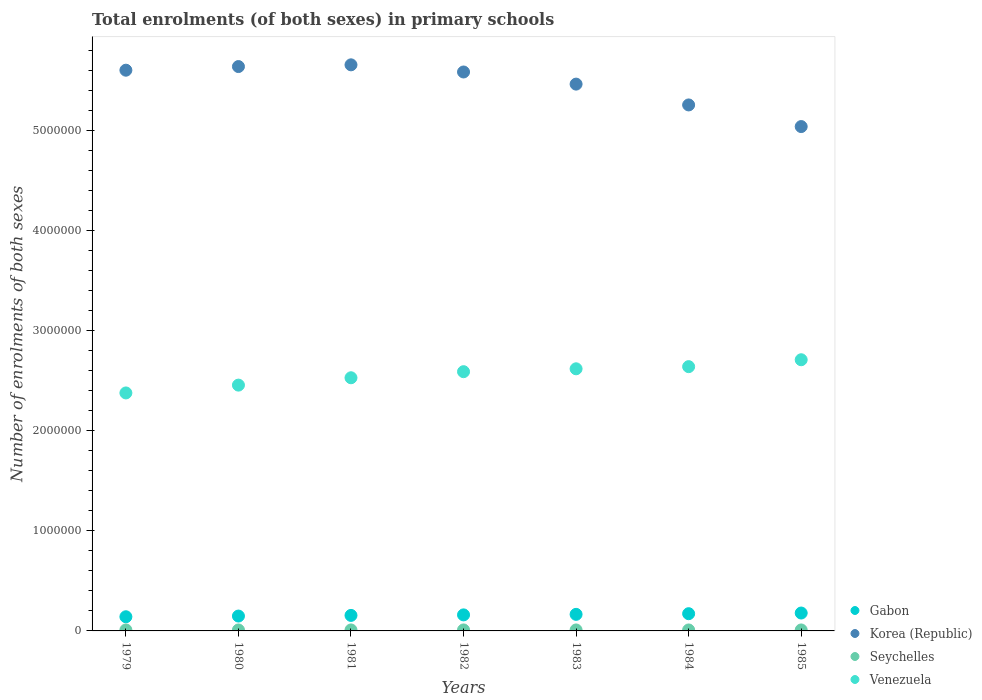What is the number of enrolments in primary schools in Korea (Republic) in 1980?
Provide a succinct answer. 5.64e+06. Across all years, what is the maximum number of enrolments in primary schools in Gabon?
Provide a succinct answer. 1.79e+05. Across all years, what is the minimum number of enrolments in primary schools in Venezuela?
Provide a short and direct response. 2.38e+06. In which year was the number of enrolments in primary schools in Seychelles maximum?
Your answer should be compact. 1979. In which year was the number of enrolments in primary schools in Venezuela minimum?
Give a very brief answer. 1979. What is the total number of enrolments in primary schools in Gabon in the graph?
Make the answer very short. 1.12e+06. What is the difference between the number of enrolments in primary schools in Seychelles in 1979 and that in 1980?
Ensure brevity in your answer.  349. What is the difference between the number of enrolments in primary schools in Seychelles in 1983 and the number of enrolments in primary schools in Gabon in 1981?
Offer a very short reply. -1.45e+05. What is the average number of enrolments in primary schools in Gabon per year?
Provide a short and direct response. 1.60e+05. In the year 1980, what is the difference between the number of enrolments in primary schools in Seychelles and number of enrolments in primary schools in Korea (Republic)?
Your answer should be very brief. -5.63e+06. In how many years, is the number of enrolments in primary schools in Gabon greater than 800000?
Provide a short and direct response. 0. What is the ratio of the number of enrolments in primary schools in Seychelles in 1983 to that in 1985?
Provide a succinct answer. 1.01. Is the number of enrolments in primary schools in Gabon in 1982 less than that in 1984?
Give a very brief answer. Yes. What is the difference between the highest and the second highest number of enrolments in primary schools in Gabon?
Offer a very short reply. 6612. What is the difference between the highest and the lowest number of enrolments in primary schools in Seychelles?
Provide a short and direct response. 371. In how many years, is the number of enrolments in primary schools in Korea (Republic) greater than the average number of enrolments in primary schools in Korea (Republic) taken over all years?
Offer a very short reply. 5. Is it the case that in every year, the sum of the number of enrolments in primary schools in Gabon and number of enrolments in primary schools in Venezuela  is greater than the sum of number of enrolments in primary schools in Korea (Republic) and number of enrolments in primary schools in Seychelles?
Offer a very short reply. No. Does the number of enrolments in primary schools in Korea (Republic) monotonically increase over the years?
Provide a short and direct response. No. Is the number of enrolments in primary schools in Seychelles strictly less than the number of enrolments in primary schools in Venezuela over the years?
Ensure brevity in your answer.  Yes. How many dotlines are there?
Your answer should be very brief. 4. How many years are there in the graph?
Your answer should be very brief. 7. Does the graph contain any zero values?
Give a very brief answer. No. Does the graph contain grids?
Make the answer very short. No. Where does the legend appear in the graph?
Provide a succinct answer. Bottom right. How many legend labels are there?
Offer a very short reply. 4. What is the title of the graph?
Your answer should be very brief. Total enrolments (of both sexes) in primary schools. What is the label or title of the Y-axis?
Your response must be concise. Number of enrolments of both sexes. What is the Number of enrolments of both sexes of Gabon in 1979?
Your answer should be compact. 1.42e+05. What is the Number of enrolments of both sexes of Korea (Republic) in 1979?
Provide a short and direct response. 5.60e+06. What is the Number of enrolments of both sexes in Seychelles in 1979?
Provide a short and direct response. 9978. What is the Number of enrolments of both sexes of Venezuela in 1979?
Give a very brief answer. 2.38e+06. What is the Number of enrolments of both sexes in Gabon in 1980?
Offer a very short reply. 1.49e+05. What is the Number of enrolments of both sexes in Korea (Republic) in 1980?
Give a very brief answer. 5.64e+06. What is the Number of enrolments of both sexes of Seychelles in 1980?
Keep it short and to the point. 9629. What is the Number of enrolments of both sexes in Venezuela in 1980?
Make the answer very short. 2.46e+06. What is the Number of enrolments of both sexes of Gabon in 1981?
Give a very brief answer. 1.55e+05. What is the Number of enrolments of both sexes in Korea (Republic) in 1981?
Ensure brevity in your answer.  5.66e+06. What is the Number of enrolments of both sexes of Seychelles in 1981?
Your response must be concise. 9790. What is the Number of enrolments of both sexes of Venezuela in 1981?
Keep it short and to the point. 2.53e+06. What is the Number of enrolments of both sexes in Gabon in 1982?
Offer a terse response. 1.60e+05. What is the Number of enrolments of both sexes in Korea (Republic) in 1982?
Offer a very short reply. 5.59e+06. What is the Number of enrolments of both sexes in Seychelles in 1982?
Ensure brevity in your answer.  9897. What is the Number of enrolments of both sexes in Venezuela in 1982?
Offer a terse response. 2.59e+06. What is the Number of enrolments of both sexes in Gabon in 1983?
Provide a short and direct response. 1.66e+05. What is the Number of enrolments of both sexes in Korea (Republic) in 1983?
Your answer should be compact. 5.47e+06. What is the Number of enrolments of both sexes in Seychelles in 1983?
Offer a very short reply. 9820. What is the Number of enrolments of both sexes in Venezuela in 1983?
Your answer should be very brief. 2.62e+06. What is the Number of enrolments of both sexes in Gabon in 1984?
Offer a terse response. 1.72e+05. What is the Number of enrolments of both sexes in Korea (Republic) in 1984?
Keep it short and to the point. 5.26e+06. What is the Number of enrolments of both sexes in Seychelles in 1984?
Ensure brevity in your answer.  9607. What is the Number of enrolments of both sexes of Venezuela in 1984?
Provide a succinct answer. 2.64e+06. What is the Number of enrolments of both sexes in Gabon in 1985?
Ensure brevity in your answer.  1.79e+05. What is the Number of enrolments of both sexes of Korea (Republic) in 1985?
Your answer should be compact. 5.04e+06. What is the Number of enrolments of both sexes in Seychelles in 1985?
Make the answer very short. 9678. What is the Number of enrolments of both sexes of Venezuela in 1985?
Your answer should be very brief. 2.71e+06. Across all years, what is the maximum Number of enrolments of both sexes in Gabon?
Offer a terse response. 1.79e+05. Across all years, what is the maximum Number of enrolments of both sexes in Korea (Republic)?
Provide a succinct answer. 5.66e+06. Across all years, what is the maximum Number of enrolments of both sexes of Seychelles?
Provide a short and direct response. 9978. Across all years, what is the maximum Number of enrolments of both sexes in Venezuela?
Keep it short and to the point. 2.71e+06. Across all years, what is the minimum Number of enrolments of both sexes in Gabon?
Offer a very short reply. 1.42e+05. Across all years, what is the minimum Number of enrolments of both sexes of Korea (Republic)?
Make the answer very short. 5.04e+06. Across all years, what is the minimum Number of enrolments of both sexes in Seychelles?
Your response must be concise. 9607. Across all years, what is the minimum Number of enrolments of both sexes of Venezuela?
Your response must be concise. 2.38e+06. What is the total Number of enrolments of both sexes in Gabon in the graph?
Provide a succinct answer. 1.12e+06. What is the total Number of enrolments of both sexes of Korea (Republic) in the graph?
Provide a short and direct response. 3.83e+07. What is the total Number of enrolments of both sexes in Seychelles in the graph?
Offer a terse response. 6.84e+04. What is the total Number of enrolments of both sexes in Venezuela in the graph?
Your answer should be compact. 1.79e+07. What is the difference between the Number of enrolments of both sexes in Gabon in 1979 and that in 1980?
Offer a terse response. -6951. What is the difference between the Number of enrolments of both sexes of Korea (Republic) in 1979 and that in 1980?
Provide a succinct answer. -3.63e+04. What is the difference between the Number of enrolments of both sexes in Seychelles in 1979 and that in 1980?
Your response must be concise. 349. What is the difference between the Number of enrolments of both sexes of Venezuela in 1979 and that in 1980?
Offer a terse response. -7.82e+04. What is the difference between the Number of enrolments of both sexes in Gabon in 1979 and that in 1981?
Your answer should be compact. -1.35e+04. What is the difference between the Number of enrolments of both sexes in Korea (Republic) in 1979 and that in 1981?
Ensure brevity in your answer.  -5.36e+04. What is the difference between the Number of enrolments of both sexes in Seychelles in 1979 and that in 1981?
Provide a short and direct response. 188. What is the difference between the Number of enrolments of both sexes in Venezuela in 1979 and that in 1981?
Your answer should be compact. -1.52e+05. What is the difference between the Number of enrolments of both sexes in Gabon in 1979 and that in 1982?
Provide a succinct answer. -1.88e+04. What is the difference between the Number of enrolments of both sexes in Korea (Republic) in 1979 and that in 1982?
Provide a succinct answer. 1.79e+04. What is the difference between the Number of enrolments of both sexes of Seychelles in 1979 and that in 1982?
Give a very brief answer. 81. What is the difference between the Number of enrolments of both sexes in Venezuela in 1979 and that in 1982?
Your response must be concise. -2.12e+05. What is the difference between the Number of enrolments of both sexes in Gabon in 1979 and that in 1983?
Provide a succinct answer. -2.40e+04. What is the difference between the Number of enrolments of both sexes in Korea (Republic) in 1979 and that in 1983?
Your answer should be very brief. 1.39e+05. What is the difference between the Number of enrolments of both sexes of Seychelles in 1979 and that in 1983?
Provide a succinct answer. 158. What is the difference between the Number of enrolments of both sexes in Venezuela in 1979 and that in 1983?
Provide a succinct answer. -2.41e+05. What is the difference between the Number of enrolments of both sexes in Gabon in 1979 and that in 1984?
Give a very brief answer. -3.06e+04. What is the difference between the Number of enrolments of both sexes in Korea (Republic) in 1979 and that in 1984?
Offer a terse response. 3.47e+05. What is the difference between the Number of enrolments of both sexes of Seychelles in 1979 and that in 1984?
Give a very brief answer. 371. What is the difference between the Number of enrolments of both sexes of Venezuela in 1979 and that in 1984?
Offer a very short reply. -2.63e+05. What is the difference between the Number of enrolments of both sexes of Gabon in 1979 and that in 1985?
Keep it short and to the point. -3.72e+04. What is the difference between the Number of enrolments of both sexes in Korea (Republic) in 1979 and that in 1985?
Keep it short and to the point. 5.63e+05. What is the difference between the Number of enrolments of both sexes of Seychelles in 1979 and that in 1985?
Provide a short and direct response. 300. What is the difference between the Number of enrolments of both sexes of Venezuela in 1979 and that in 1985?
Give a very brief answer. -3.32e+05. What is the difference between the Number of enrolments of both sexes of Gabon in 1980 and that in 1981?
Keep it short and to the point. -6561. What is the difference between the Number of enrolments of both sexes in Korea (Republic) in 1980 and that in 1981?
Provide a short and direct response. -1.73e+04. What is the difference between the Number of enrolments of both sexes in Seychelles in 1980 and that in 1981?
Offer a terse response. -161. What is the difference between the Number of enrolments of both sexes of Venezuela in 1980 and that in 1981?
Make the answer very short. -7.34e+04. What is the difference between the Number of enrolments of both sexes in Gabon in 1980 and that in 1982?
Give a very brief answer. -1.18e+04. What is the difference between the Number of enrolments of both sexes of Korea (Republic) in 1980 and that in 1982?
Provide a short and direct response. 5.42e+04. What is the difference between the Number of enrolments of both sexes in Seychelles in 1980 and that in 1982?
Provide a short and direct response. -268. What is the difference between the Number of enrolments of both sexes in Venezuela in 1980 and that in 1982?
Offer a very short reply. -1.34e+05. What is the difference between the Number of enrolments of both sexes in Gabon in 1980 and that in 1983?
Offer a terse response. -1.70e+04. What is the difference between the Number of enrolments of both sexes in Korea (Republic) in 1980 and that in 1983?
Your answer should be very brief. 1.75e+05. What is the difference between the Number of enrolments of both sexes in Seychelles in 1980 and that in 1983?
Make the answer very short. -191. What is the difference between the Number of enrolments of both sexes of Venezuela in 1980 and that in 1983?
Your answer should be compact. -1.63e+05. What is the difference between the Number of enrolments of both sexes of Gabon in 1980 and that in 1984?
Your answer should be compact. -2.37e+04. What is the difference between the Number of enrolments of both sexes in Korea (Republic) in 1980 and that in 1984?
Offer a very short reply. 3.84e+05. What is the difference between the Number of enrolments of both sexes in Seychelles in 1980 and that in 1984?
Ensure brevity in your answer.  22. What is the difference between the Number of enrolments of both sexes in Venezuela in 1980 and that in 1984?
Provide a short and direct response. -1.85e+05. What is the difference between the Number of enrolments of both sexes in Gabon in 1980 and that in 1985?
Your answer should be very brief. -3.03e+04. What is the difference between the Number of enrolments of both sexes of Korea (Republic) in 1980 and that in 1985?
Make the answer very short. 6.00e+05. What is the difference between the Number of enrolments of both sexes in Seychelles in 1980 and that in 1985?
Make the answer very short. -49. What is the difference between the Number of enrolments of both sexes in Venezuela in 1980 and that in 1985?
Ensure brevity in your answer.  -2.54e+05. What is the difference between the Number of enrolments of both sexes of Gabon in 1981 and that in 1982?
Your response must be concise. -5268. What is the difference between the Number of enrolments of both sexes in Korea (Republic) in 1981 and that in 1982?
Your answer should be very brief. 7.15e+04. What is the difference between the Number of enrolments of both sexes of Seychelles in 1981 and that in 1982?
Keep it short and to the point. -107. What is the difference between the Number of enrolments of both sexes of Venezuela in 1981 and that in 1982?
Your answer should be very brief. -6.08e+04. What is the difference between the Number of enrolments of both sexes of Gabon in 1981 and that in 1983?
Provide a succinct answer. -1.05e+04. What is the difference between the Number of enrolments of both sexes of Korea (Republic) in 1981 and that in 1983?
Ensure brevity in your answer.  1.93e+05. What is the difference between the Number of enrolments of both sexes of Seychelles in 1981 and that in 1983?
Provide a short and direct response. -30. What is the difference between the Number of enrolments of both sexes of Venezuela in 1981 and that in 1983?
Provide a succinct answer. -8.96e+04. What is the difference between the Number of enrolments of both sexes in Gabon in 1981 and that in 1984?
Your answer should be very brief. -1.71e+04. What is the difference between the Number of enrolments of both sexes in Korea (Republic) in 1981 and that in 1984?
Provide a short and direct response. 4.01e+05. What is the difference between the Number of enrolments of both sexes in Seychelles in 1981 and that in 1984?
Give a very brief answer. 183. What is the difference between the Number of enrolments of both sexes in Venezuela in 1981 and that in 1984?
Your answer should be very brief. -1.11e+05. What is the difference between the Number of enrolments of both sexes of Gabon in 1981 and that in 1985?
Offer a terse response. -2.37e+04. What is the difference between the Number of enrolments of both sexes of Korea (Republic) in 1981 and that in 1985?
Offer a very short reply. 6.17e+05. What is the difference between the Number of enrolments of both sexes of Seychelles in 1981 and that in 1985?
Offer a terse response. 112. What is the difference between the Number of enrolments of both sexes in Venezuela in 1981 and that in 1985?
Provide a succinct answer. -1.80e+05. What is the difference between the Number of enrolments of both sexes in Gabon in 1982 and that in 1983?
Give a very brief answer. -5210. What is the difference between the Number of enrolments of both sexes in Korea (Republic) in 1982 and that in 1983?
Your answer should be very brief. 1.21e+05. What is the difference between the Number of enrolments of both sexes of Seychelles in 1982 and that in 1983?
Your response must be concise. 77. What is the difference between the Number of enrolments of both sexes of Venezuela in 1982 and that in 1983?
Your answer should be compact. -2.88e+04. What is the difference between the Number of enrolments of both sexes of Gabon in 1982 and that in 1984?
Your answer should be very brief. -1.19e+04. What is the difference between the Number of enrolments of both sexes in Korea (Republic) in 1982 and that in 1984?
Provide a succinct answer. 3.29e+05. What is the difference between the Number of enrolments of both sexes in Seychelles in 1982 and that in 1984?
Provide a succinct answer. 290. What is the difference between the Number of enrolments of both sexes of Venezuela in 1982 and that in 1984?
Make the answer very short. -5.03e+04. What is the difference between the Number of enrolments of both sexes in Gabon in 1982 and that in 1985?
Your answer should be compact. -1.85e+04. What is the difference between the Number of enrolments of both sexes in Korea (Republic) in 1982 and that in 1985?
Give a very brief answer. 5.46e+05. What is the difference between the Number of enrolments of both sexes in Seychelles in 1982 and that in 1985?
Ensure brevity in your answer.  219. What is the difference between the Number of enrolments of both sexes in Venezuela in 1982 and that in 1985?
Offer a very short reply. -1.19e+05. What is the difference between the Number of enrolments of both sexes of Gabon in 1983 and that in 1984?
Provide a succinct answer. -6642. What is the difference between the Number of enrolments of both sexes in Korea (Republic) in 1983 and that in 1984?
Make the answer very short. 2.08e+05. What is the difference between the Number of enrolments of both sexes in Seychelles in 1983 and that in 1984?
Offer a terse response. 213. What is the difference between the Number of enrolments of both sexes of Venezuela in 1983 and that in 1984?
Make the answer very short. -2.15e+04. What is the difference between the Number of enrolments of both sexes of Gabon in 1983 and that in 1985?
Give a very brief answer. -1.33e+04. What is the difference between the Number of enrolments of both sexes in Korea (Republic) in 1983 and that in 1985?
Provide a short and direct response. 4.24e+05. What is the difference between the Number of enrolments of both sexes of Seychelles in 1983 and that in 1985?
Give a very brief answer. 142. What is the difference between the Number of enrolments of both sexes in Venezuela in 1983 and that in 1985?
Make the answer very short. -9.05e+04. What is the difference between the Number of enrolments of both sexes in Gabon in 1984 and that in 1985?
Your answer should be very brief. -6612. What is the difference between the Number of enrolments of both sexes in Korea (Republic) in 1984 and that in 1985?
Provide a short and direct response. 2.16e+05. What is the difference between the Number of enrolments of both sexes in Seychelles in 1984 and that in 1985?
Provide a short and direct response. -71. What is the difference between the Number of enrolments of both sexes in Venezuela in 1984 and that in 1985?
Offer a terse response. -6.90e+04. What is the difference between the Number of enrolments of both sexes in Gabon in 1979 and the Number of enrolments of both sexes in Korea (Republic) in 1980?
Make the answer very short. -5.50e+06. What is the difference between the Number of enrolments of both sexes in Gabon in 1979 and the Number of enrolments of both sexes in Seychelles in 1980?
Provide a succinct answer. 1.32e+05. What is the difference between the Number of enrolments of both sexes of Gabon in 1979 and the Number of enrolments of both sexes of Venezuela in 1980?
Your answer should be very brief. -2.32e+06. What is the difference between the Number of enrolments of both sexes of Korea (Republic) in 1979 and the Number of enrolments of both sexes of Seychelles in 1980?
Ensure brevity in your answer.  5.59e+06. What is the difference between the Number of enrolments of both sexes of Korea (Republic) in 1979 and the Number of enrolments of both sexes of Venezuela in 1980?
Provide a short and direct response. 3.15e+06. What is the difference between the Number of enrolments of both sexes of Seychelles in 1979 and the Number of enrolments of both sexes of Venezuela in 1980?
Your answer should be very brief. -2.45e+06. What is the difference between the Number of enrolments of both sexes of Gabon in 1979 and the Number of enrolments of both sexes of Korea (Republic) in 1981?
Your answer should be compact. -5.52e+06. What is the difference between the Number of enrolments of both sexes in Gabon in 1979 and the Number of enrolments of both sexes in Seychelles in 1981?
Make the answer very short. 1.32e+05. What is the difference between the Number of enrolments of both sexes in Gabon in 1979 and the Number of enrolments of both sexes in Venezuela in 1981?
Provide a short and direct response. -2.39e+06. What is the difference between the Number of enrolments of both sexes in Korea (Republic) in 1979 and the Number of enrolments of both sexes in Seychelles in 1981?
Keep it short and to the point. 5.59e+06. What is the difference between the Number of enrolments of both sexes of Korea (Republic) in 1979 and the Number of enrolments of both sexes of Venezuela in 1981?
Give a very brief answer. 3.07e+06. What is the difference between the Number of enrolments of both sexes of Seychelles in 1979 and the Number of enrolments of both sexes of Venezuela in 1981?
Make the answer very short. -2.52e+06. What is the difference between the Number of enrolments of both sexes in Gabon in 1979 and the Number of enrolments of both sexes in Korea (Republic) in 1982?
Provide a succinct answer. -5.44e+06. What is the difference between the Number of enrolments of both sexes of Gabon in 1979 and the Number of enrolments of both sexes of Seychelles in 1982?
Give a very brief answer. 1.32e+05. What is the difference between the Number of enrolments of both sexes of Gabon in 1979 and the Number of enrolments of both sexes of Venezuela in 1982?
Your response must be concise. -2.45e+06. What is the difference between the Number of enrolments of both sexes of Korea (Republic) in 1979 and the Number of enrolments of both sexes of Seychelles in 1982?
Offer a very short reply. 5.59e+06. What is the difference between the Number of enrolments of both sexes of Korea (Republic) in 1979 and the Number of enrolments of both sexes of Venezuela in 1982?
Offer a very short reply. 3.01e+06. What is the difference between the Number of enrolments of both sexes in Seychelles in 1979 and the Number of enrolments of both sexes in Venezuela in 1982?
Give a very brief answer. -2.58e+06. What is the difference between the Number of enrolments of both sexes of Gabon in 1979 and the Number of enrolments of both sexes of Korea (Republic) in 1983?
Your answer should be very brief. -5.32e+06. What is the difference between the Number of enrolments of both sexes in Gabon in 1979 and the Number of enrolments of both sexes in Seychelles in 1983?
Provide a succinct answer. 1.32e+05. What is the difference between the Number of enrolments of both sexes in Gabon in 1979 and the Number of enrolments of both sexes in Venezuela in 1983?
Your answer should be compact. -2.48e+06. What is the difference between the Number of enrolments of both sexes in Korea (Republic) in 1979 and the Number of enrolments of both sexes in Seychelles in 1983?
Your answer should be compact. 5.59e+06. What is the difference between the Number of enrolments of both sexes in Korea (Republic) in 1979 and the Number of enrolments of both sexes in Venezuela in 1983?
Provide a succinct answer. 2.98e+06. What is the difference between the Number of enrolments of both sexes in Seychelles in 1979 and the Number of enrolments of both sexes in Venezuela in 1983?
Ensure brevity in your answer.  -2.61e+06. What is the difference between the Number of enrolments of both sexes of Gabon in 1979 and the Number of enrolments of both sexes of Korea (Republic) in 1984?
Your answer should be compact. -5.12e+06. What is the difference between the Number of enrolments of both sexes of Gabon in 1979 and the Number of enrolments of both sexes of Seychelles in 1984?
Give a very brief answer. 1.32e+05. What is the difference between the Number of enrolments of both sexes of Gabon in 1979 and the Number of enrolments of both sexes of Venezuela in 1984?
Make the answer very short. -2.50e+06. What is the difference between the Number of enrolments of both sexes in Korea (Republic) in 1979 and the Number of enrolments of both sexes in Seychelles in 1984?
Your answer should be very brief. 5.59e+06. What is the difference between the Number of enrolments of both sexes in Korea (Republic) in 1979 and the Number of enrolments of both sexes in Venezuela in 1984?
Your answer should be compact. 2.96e+06. What is the difference between the Number of enrolments of both sexes of Seychelles in 1979 and the Number of enrolments of both sexes of Venezuela in 1984?
Provide a short and direct response. -2.63e+06. What is the difference between the Number of enrolments of both sexes of Gabon in 1979 and the Number of enrolments of both sexes of Korea (Republic) in 1985?
Provide a succinct answer. -4.90e+06. What is the difference between the Number of enrolments of both sexes of Gabon in 1979 and the Number of enrolments of both sexes of Seychelles in 1985?
Your answer should be very brief. 1.32e+05. What is the difference between the Number of enrolments of both sexes in Gabon in 1979 and the Number of enrolments of both sexes in Venezuela in 1985?
Your response must be concise. -2.57e+06. What is the difference between the Number of enrolments of both sexes of Korea (Republic) in 1979 and the Number of enrolments of both sexes of Seychelles in 1985?
Your answer should be very brief. 5.59e+06. What is the difference between the Number of enrolments of both sexes in Korea (Republic) in 1979 and the Number of enrolments of both sexes in Venezuela in 1985?
Provide a short and direct response. 2.89e+06. What is the difference between the Number of enrolments of both sexes of Seychelles in 1979 and the Number of enrolments of both sexes of Venezuela in 1985?
Make the answer very short. -2.70e+06. What is the difference between the Number of enrolments of both sexes of Gabon in 1980 and the Number of enrolments of both sexes of Korea (Republic) in 1981?
Your response must be concise. -5.51e+06. What is the difference between the Number of enrolments of both sexes of Gabon in 1980 and the Number of enrolments of both sexes of Seychelles in 1981?
Provide a short and direct response. 1.39e+05. What is the difference between the Number of enrolments of both sexes in Gabon in 1980 and the Number of enrolments of both sexes in Venezuela in 1981?
Offer a very short reply. -2.38e+06. What is the difference between the Number of enrolments of both sexes in Korea (Republic) in 1980 and the Number of enrolments of both sexes in Seychelles in 1981?
Give a very brief answer. 5.63e+06. What is the difference between the Number of enrolments of both sexes of Korea (Republic) in 1980 and the Number of enrolments of both sexes of Venezuela in 1981?
Provide a succinct answer. 3.11e+06. What is the difference between the Number of enrolments of both sexes of Seychelles in 1980 and the Number of enrolments of both sexes of Venezuela in 1981?
Your response must be concise. -2.52e+06. What is the difference between the Number of enrolments of both sexes of Gabon in 1980 and the Number of enrolments of both sexes of Korea (Republic) in 1982?
Offer a terse response. -5.44e+06. What is the difference between the Number of enrolments of both sexes of Gabon in 1980 and the Number of enrolments of both sexes of Seychelles in 1982?
Offer a very short reply. 1.39e+05. What is the difference between the Number of enrolments of both sexes of Gabon in 1980 and the Number of enrolments of both sexes of Venezuela in 1982?
Your answer should be very brief. -2.44e+06. What is the difference between the Number of enrolments of both sexes in Korea (Republic) in 1980 and the Number of enrolments of both sexes in Seychelles in 1982?
Your answer should be very brief. 5.63e+06. What is the difference between the Number of enrolments of both sexes of Korea (Republic) in 1980 and the Number of enrolments of both sexes of Venezuela in 1982?
Give a very brief answer. 3.05e+06. What is the difference between the Number of enrolments of both sexes of Seychelles in 1980 and the Number of enrolments of both sexes of Venezuela in 1982?
Keep it short and to the point. -2.58e+06. What is the difference between the Number of enrolments of both sexes in Gabon in 1980 and the Number of enrolments of both sexes in Korea (Republic) in 1983?
Provide a succinct answer. -5.32e+06. What is the difference between the Number of enrolments of both sexes in Gabon in 1980 and the Number of enrolments of both sexes in Seychelles in 1983?
Provide a succinct answer. 1.39e+05. What is the difference between the Number of enrolments of both sexes in Gabon in 1980 and the Number of enrolments of both sexes in Venezuela in 1983?
Ensure brevity in your answer.  -2.47e+06. What is the difference between the Number of enrolments of both sexes in Korea (Republic) in 1980 and the Number of enrolments of both sexes in Seychelles in 1983?
Provide a succinct answer. 5.63e+06. What is the difference between the Number of enrolments of both sexes in Korea (Republic) in 1980 and the Number of enrolments of both sexes in Venezuela in 1983?
Offer a terse response. 3.02e+06. What is the difference between the Number of enrolments of both sexes in Seychelles in 1980 and the Number of enrolments of both sexes in Venezuela in 1983?
Keep it short and to the point. -2.61e+06. What is the difference between the Number of enrolments of both sexes of Gabon in 1980 and the Number of enrolments of both sexes of Korea (Republic) in 1984?
Make the answer very short. -5.11e+06. What is the difference between the Number of enrolments of both sexes of Gabon in 1980 and the Number of enrolments of both sexes of Seychelles in 1984?
Your answer should be very brief. 1.39e+05. What is the difference between the Number of enrolments of both sexes of Gabon in 1980 and the Number of enrolments of both sexes of Venezuela in 1984?
Ensure brevity in your answer.  -2.49e+06. What is the difference between the Number of enrolments of both sexes in Korea (Republic) in 1980 and the Number of enrolments of both sexes in Seychelles in 1984?
Keep it short and to the point. 5.63e+06. What is the difference between the Number of enrolments of both sexes in Korea (Republic) in 1980 and the Number of enrolments of both sexes in Venezuela in 1984?
Provide a succinct answer. 3.00e+06. What is the difference between the Number of enrolments of both sexes in Seychelles in 1980 and the Number of enrolments of both sexes in Venezuela in 1984?
Your response must be concise. -2.63e+06. What is the difference between the Number of enrolments of both sexes in Gabon in 1980 and the Number of enrolments of both sexes in Korea (Republic) in 1985?
Your answer should be compact. -4.89e+06. What is the difference between the Number of enrolments of both sexes in Gabon in 1980 and the Number of enrolments of both sexes in Seychelles in 1985?
Make the answer very short. 1.39e+05. What is the difference between the Number of enrolments of both sexes of Gabon in 1980 and the Number of enrolments of both sexes of Venezuela in 1985?
Offer a very short reply. -2.56e+06. What is the difference between the Number of enrolments of both sexes in Korea (Republic) in 1980 and the Number of enrolments of both sexes in Seychelles in 1985?
Provide a succinct answer. 5.63e+06. What is the difference between the Number of enrolments of both sexes of Korea (Republic) in 1980 and the Number of enrolments of both sexes of Venezuela in 1985?
Offer a very short reply. 2.93e+06. What is the difference between the Number of enrolments of both sexes in Seychelles in 1980 and the Number of enrolments of both sexes in Venezuela in 1985?
Ensure brevity in your answer.  -2.70e+06. What is the difference between the Number of enrolments of both sexes of Gabon in 1981 and the Number of enrolments of both sexes of Korea (Republic) in 1982?
Provide a short and direct response. -5.43e+06. What is the difference between the Number of enrolments of both sexes in Gabon in 1981 and the Number of enrolments of both sexes in Seychelles in 1982?
Offer a very short reply. 1.45e+05. What is the difference between the Number of enrolments of both sexes in Gabon in 1981 and the Number of enrolments of both sexes in Venezuela in 1982?
Provide a succinct answer. -2.44e+06. What is the difference between the Number of enrolments of both sexes of Korea (Republic) in 1981 and the Number of enrolments of both sexes of Seychelles in 1982?
Give a very brief answer. 5.65e+06. What is the difference between the Number of enrolments of both sexes of Korea (Republic) in 1981 and the Number of enrolments of both sexes of Venezuela in 1982?
Ensure brevity in your answer.  3.07e+06. What is the difference between the Number of enrolments of both sexes in Seychelles in 1981 and the Number of enrolments of both sexes in Venezuela in 1982?
Offer a very short reply. -2.58e+06. What is the difference between the Number of enrolments of both sexes in Gabon in 1981 and the Number of enrolments of both sexes in Korea (Republic) in 1983?
Make the answer very short. -5.31e+06. What is the difference between the Number of enrolments of both sexes of Gabon in 1981 and the Number of enrolments of both sexes of Seychelles in 1983?
Offer a very short reply. 1.45e+05. What is the difference between the Number of enrolments of both sexes of Gabon in 1981 and the Number of enrolments of both sexes of Venezuela in 1983?
Offer a terse response. -2.46e+06. What is the difference between the Number of enrolments of both sexes in Korea (Republic) in 1981 and the Number of enrolments of both sexes in Seychelles in 1983?
Provide a succinct answer. 5.65e+06. What is the difference between the Number of enrolments of both sexes of Korea (Republic) in 1981 and the Number of enrolments of both sexes of Venezuela in 1983?
Keep it short and to the point. 3.04e+06. What is the difference between the Number of enrolments of both sexes of Seychelles in 1981 and the Number of enrolments of both sexes of Venezuela in 1983?
Keep it short and to the point. -2.61e+06. What is the difference between the Number of enrolments of both sexes of Gabon in 1981 and the Number of enrolments of both sexes of Korea (Republic) in 1984?
Provide a succinct answer. -5.10e+06. What is the difference between the Number of enrolments of both sexes in Gabon in 1981 and the Number of enrolments of both sexes in Seychelles in 1984?
Your answer should be compact. 1.45e+05. What is the difference between the Number of enrolments of both sexes in Gabon in 1981 and the Number of enrolments of both sexes in Venezuela in 1984?
Provide a short and direct response. -2.49e+06. What is the difference between the Number of enrolments of both sexes of Korea (Republic) in 1981 and the Number of enrolments of both sexes of Seychelles in 1984?
Offer a very short reply. 5.65e+06. What is the difference between the Number of enrolments of both sexes in Korea (Republic) in 1981 and the Number of enrolments of both sexes in Venezuela in 1984?
Keep it short and to the point. 3.02e+06. What is the difference between the Number of enrolments of both sexes in Seychelles in 1981 and the Number of enrolments of both sexes in Venezuela in 1984?
Offer a terse response. -2.63e+06. What is the difference between the Number of enrolments of both sexes of Gabon in 1981 and the Number of enrolments of both sexes of Korea (Republic) in 1985?
Make the answer very short. -4.89e+06. What is the difference between the Number of enrolments of both sexes of Gabon in 1981 and the Number of enrolments of both sexes of Seychelles in 1985?
Provide a short and direct response. 1.45e+05. What is the difference between the Number of enrolments of both sexes in Gabon in 1981 and the Number of enrolments of both sexes in Venezuela in 1985?
Offer a terse response. -2.56e+06. What is the difference between the Number of enrolments of both sexes in Korea (Republic) in 1981 and the Number of enrolments of both sexes in Seychelles in 1985?
Ensure brevity in your answer.  5.65e+06. What is the difference between the Number of enrolments of both sexes of Korea (Republic) in 1981 and the Number of enrolments of both sexes of Venezuela in 1985?
Ensure brevity in your answer.  2.95e+06. What is the difference between the Number of enrolments of both sexes of Seychelles in 1981 and the Number of enrolments of both sexes of Venezuela in 1985?
Keep it short and to the point. -2.70e+06. What is the difference between the Number of enrolments of both sexes of Gabon in 1982 and the Number of enrolments of both sexes of Korea (Republic) in 1983?
Offer a very short reply. -5.30e+06. What is the difference between the Number of enrolments of both sexes of Gabon in 1982 and the Number of enrolments of both sexes of Seychelles in 1983?
Provide a succinct answer. 1.51e+05. What is the difference between the Number of enrolments of both sexes of Gabon in 1982 and the Number of enrolments of both sexes of Venezuela in 1983?
Make the answer very short. -2.46e+06. What is the difference between the Number of enrolments of both sexes of Korea (Republic) in 1982 and the Number of enrolments of both sexes of Seychelles in 1983?
Offer a terse response. 5.58e+06. What is the difference between the Number of enrolments of both sexes of Korea (Republic) in 1982 and the Number of enrolments of both sexes of Venezuela in 1983?
Provide a succinct answer. 2.97e+06. What is the difference between the Number of enrolments of both sexes in Seychelles in 1982 and the Number of enrolments of both sexes in Venezuela in 1983?
Offer a terse response. -2.61e+06. What is the difference between the Number of enrolments of both sexes of Gabon in 1982 and the Number of enrolments of both sexes of Korea (Republic) in 1984?
Offer a terse response. -5.10e+06. What is the difference between the Number of enrolments of both sexes in Gabon in 1982 and the Number of enrolments of both sexes in Seychelles in 1984?
Give a very brief answer. 1.51e+05. What is the difference between the Number of enrolments of both sexes of Gabon in 1982 and the Number of enrolments of both sexes of Venezuela in 1984?
Provide a short and direct response. -2.48e+06. What is the difference between the Number of enrolments of both sexes in Korea (Republic) in 1982 and the Number of enrolments of both sexes in Seychelles in 1984?
Ensure brevity in your answer.  5.58e+06. What is the difference between the Number of enrolments of both sexes in Korea (Republic) in 1982 and the Number of enrolments of both sexes in Venezuela in 1984?
Provide a short and direct response. 2.95e+06. What is the difference between the Number of enrolments of both sexes of Seychelles in 1982 and the Number of enrolments of both sexes of Venezuela in 1984?
Ensure brevity in your answer.  -2.63e+06. What is the difference between the Number of enrolments of both sexes in Gabon in 1982 and the Number of enrolments of both sexes in Korea (Republic) in 1985?
Provide a short and direct response. -4.88e+06. What is the difference between the Number of enrolments of both sexes of Gabon in 1982 and the Number of enrolments of both sexes of Seychelles in 1985?
Provide a short and direct response. 1.51e+05. What is the difference between the Number of enrolments of both sexes in Gabon in 1982 and the Number of enrolments of both sexes in Venezuela in 1985?
Keep it short and to the point. -2.55e+06. What is the difference between the Number of enrolments of both sexes in Korea (Republic) in 1982 and the Number of enrolments of both sexes in Seychelles in 1985?
Your answer should be very brief. 5.58e+06. What is the difference between the Number of enrolments of both sexes in Korea (Republic) in 1982 and the Number of enrolments of both sexes in Venezuela in 1985?
Make the answer very short. 2.88e+06. What is the difference between the Number of enrolments of both sexes of Seychelles in 1982 and the Number of enrolments of both sexes of Venezuela in 1985?
Ensure brevity in your answer.  -2.70e+06. What is the difference between the Number of enrolments of both sexes in Gabon in 1983 and the Number of enrolments of both sexes in Korea (Republic) in 1984?
Your answer should be very brief. -5.09e+06. What is the difference between the Number of enrolments of both sexes in Gabon in 1983 and the Number of enrolments of both sexes in Seychelles in 1984?
Your answer should be compact. 1.56e+05. What is the difference between the Number of enrolments of both sexes of Gabon in 1983 and the Number of enrolments of both sexes of Venezuela in 1984?
Offer a very short reply. -2.48e+06. What is the difference between the Number of enrolments of both sexes of Korea (Republic) in 1983 and the Number of enrolments of both sexes of Seychelles in 1984?
Give a very brief answer. 5.46e+06. What is the difference between the Number of enrolments of both sexes of Korea (Republic) in 1983 and the Number of enrolments of both sexes of Venezuela in 1984?
Offer a terse response. 2.82e+06. What is the difference between the Number of enrolments of both sexes in Seychelles in 1983 and the Number of enrolments of both sexes in Venezuela in 1984?
Provide a short and direct response. -2.63e+06. What is the difference between the Number of enrolments of both sexes in Gabon in 1983 and the Number of enrolments of both sexes in Korea (Republic) in 1985?
Provide a succinct answer. -4.88e+06. What is the difference between the Number of enrolments of both sexes of Gabon in 1983 and the Number of enrolments of both sexes of Seychelles in 1985?
Ensure brevity in your answer.  1.56e+05. What is the difference between the Number of enrolments of both sexes of Gabon in 1983 and the Number of enrolments of both sexes of Venezuela in 1985?
Offer a terse response. -2.54e+06. What is the difference between the Number of enrolments of both sexes of Korea (Republic) in 1983 and the Number of enrolments of both sexes of Seychelles in 1985?
Provide a short and direct response. 5.46e+06. What is the difference between the Number of enrolments of both sexes of Korea (Republic) in 1983 and the Number of enrolments of both sexes of Venezuela in 1985?
Offer a terse response. 2.75e+06. What is the difference between the Number of enrolments of both sexes in Seychelles in 1983 and the Number of enrolments of both sexes in Venezuela in 1985?
Offer a terse response. -2.70e+06. What is the difference between the Number of enrolments of both sexes in Gabon in 1984 and the Number of enrolments of both sexes in Korea (Republic) in 1985?
Make the answer very short. -4.87e+06. What is the difference between the Number of enrolments of both sexes in Gabon in 1984 and the Number of enrolments of both sexes in Seychelles in 1985?
Provide a succinct answer. 1.63e+05. What is the difference between the Number of enrolments of both sexes in Gabon in 1984 and the Number of enrolments of both sexes in Venezuela in 1985?
Give a very brief answer. -2.54e+06. What is the difference between the Number of enrolments of both sexes in Korea (Republic) in 1984 and the Number of enrolments of both sexes in Seychelles in 1985?
Keep it short and to the point. 5.25e+06. What is the difference between the Number of enrolments of both sexes of Korea (Republic) in 1984 and the Number of enrolments of both sexes of Venezuela in 1985?
Provide a succinct answer. 2.55e+06. What is the difference between the Number of enrolments of both sexes in Seychelles in 1984 and the Number of enrolments of both sexes in Venezuela in 1985?
Ensure brevity in your answer.  -2.70e+06. What is the average Number of enrolments of both sexes in Gabon per year?
Your answer should be compact. 1.60e+05. What is the average Number of enrolments of both sexes in Korea (Republic) per year?
Keep it short and to the point. 5.46e+06. What is the average Number of enrolments of both sexes in Seychelles per year?
Keep it short and to the point. 9771.29. What is the average Number of enrolments of both sexes in Venezuela per year?
Provide a short and direct response. 2.56e+06. In the year 1979, what is the difference between the Number of enrolments of both sexes of Gabon and Number of enrolments of both sexes of Korea (Republic)?
Ensure brevity in your answer.  -5.46e+06. In the year 1979, what is the difference between the Number of enrolments of both sexes of Gabon and Number of enrolments of both sexes of Seychelles?
Offer a terse response. 1.32e+05. In the year 1979, what is the difference between the Number of enrolments of both sexes in Gabon and Number of enrolments of both sexes in Venezuela?
Your response must be concise. -2.24e+06. In the year 1979, what is the difference between the Number of enrolments of both sexes of Korea (Republic) and Number of enrolments of both sexes of Seychelles?
Your answer should be very brief. 5.59e+06. In the year 1979, what is the difference between the Number of enrolments of both sexes in Korea (Republic) and Number of enrolments of both sexes in Venezuela?
Give a very brief answer. 3.23e+06. In the year 1979, what is the difference between the Number of enrolments of both sexes of Seychelles and Number of enrolments of both sexes of Venezuela?
Provide a short and direct response. -2.37e+06. In the year 1980, what is the difference between the Number of enrolments of both sexes of Gabon and Number of enrolments of both sexes of Korea (Republic)?
Your response must be concise. -5.49e+06. In the year 1980, what is the difference between the Number of enrolments of both sexes in Gabon and Number of enrolments of both sexes in Seychelles?
Offer a terse response. 1.39e+05. In the year 1980, what is the difference between the Number of enrolments of both sexes of Gabon and Number of enrolments of both sexes of Venezuela?
Make the answer very short. -2.31e+06. In the year 1980, what is the difference between the Number of enrolments of both sexes in Korea (Republic) and Number of enrolments of both sexes in Seychelles?
Offer a very short reply. 5.63e+06. In the year 1980, what is the difference between the Number of enrolments of both sexes in Korea (Republic) and Number of enrolments of both sexes in Venezuela?
Offer a terse response. 3.18e+06. In the year 1980, what is the difference between the Number of enrolments of both sexes in Seychelles and Number of enrolments of both sexes in Venezuela?
Your answer should be very brief. -2.45e+06. In the year 1981, what is the difference between the Number of enrolments of both sexes of Gabon and Number of enrolments of both sexes of Korea (Republic)?
Your response must be concise. -5.50e+06. In the year 1981, what is the difference between the Number of enrolments of both sexes in Gabon and Number of enrolments of both sexes in Seychelles?
Make the answer very short. 1.45e+05. In the year 1981, what is the difference between the Number of enrolments of both sexes in Gabon and Number of enrolments of both sexes in Venezuela?
Your response must be concise. -2.38e+06. In the year 1981, what is the difference between the Number of enrolments of both sexes in Korea (Republic) and Number of enrolments of both sexes in Seychelles?
Your response must be concise. 5.65e+06. In the year 1981, what is the difference between the Number of enrolments of both sexes of Korea (Republic) and Number of enrolments of both sexes of Venezuela?
Your answer should be compact. 3.13e+06. In the year 1981, what is the difference between the Number of enrolments of both sexes of Seychelles and Number of enrolments of both sexes of Venezuela?
Offer a terse response. -2.52e+06. In the year 1982, what is the difference between the Number of enrolments of both sexes in Gabon and Number of enrolments of both sexes in Korea (Republic)?
Your response must be concise. -5.43e+06. In the year 1982, what is the difference between the Number of enrolments of both sexes of Gabon and Number of enrolments of both sexes of Seychelles?
Your response must be concise. 1.50e+05. In the year 1982, what is the difference between the Number of enrolments of both sexes in Gabon and Number of enrolments of both sexes in Venezuela?
Offer a terse response. -2.43e+06. In the year 1982, what is the difference between the Number of enrolments of both sexes in Korea (Republic) and Number of enrolments of both sexes in Seychelles?
Offer a very short reply. 5.58e+06. In the year 1982, what is the difference between the Number of enrolments of both sexes in Korea (Republic) and Number of enrolments of both sexes in Venezuela?
Your answer should be very brief. 3.00e+06. In the year 1982, what is the difference between the Number of enrolments of both sexes of Seychelles and Number of enrolments of both sexes of Venezuela?
Make the answer very short. -2.58e+06. In the year 1983, what is the difference between the Number of enrolments of both sexes in Gabon and Number of enrolments of both sexes in Korea (Republic)?
Give a very brief answer. -5.30e+06. In the year 1983, what is the difference between the Number of enrolments of both sexes of Gabon and Number of enrolments of both sexes of Seychelles?
Offer a very short reply. 1.56e+05. In the year 1983, what is the difference between the Number of enrolments of both sexes in Gabon and Number of enrolments of both sexes in Venezuela?
Give a very brief answer. -2.45e+06. In the year 1983, what is the difference between the Number of enrolments of both sexes in Korea (Republic) and Number of enrolments of both sexes in Seychelles?
Make the answer very short. 5.46e+06. In the year 1983, what is the difference between the Number of enrolments of both sexes in Korea (Republic) and Number of enrolments of both sexes in Venezuela?
Keep it short and to the point. 2.85e+06. In the year 1983, what is the difference between the Number of enrolments of both sexes of Seychelles and Number of enrolments of both sexes of Venezuela?
Make the answer very short. -2.61e+06. In the year 1984, what is the difference between the Number of enrolments of both sexes in Gabon and Number of enrolments of both sexes in Korea (Republic)?
Provide a succinct answer. -5.08e+06. In the year 1984, what is the difference between the Number of enrolments of both sexes in Gabon and Number of enrolments of both sexes in Seychelles?
Your response must be concise. 1.63e+05. In the year 1984, what is the difference between the Number of enrolments of both sexes of Gabon and Number of enrolments of both sexes of Venezuela?
Offer a terse response. -2.47e+06. In the year 1984, what is the difference between the Number of enrolments of both sexes of Korea (Republic) and Number of enrolments of both sexes of Seychelles?
Keep it short and to the point. 5.25e+06. In the year 1984, what is the difference between the Number of enrolments of both sexes of Korea (Republic) and Number of enrolments of both sexes of Venezuela?
Provide a succinct answer. 2.62e+06. In the year 1984, what is the difference between the Number of enrolments of both sexes of Seychelles and Number of enrolments of both sexes of Venezuela?
Keep it short and to the point. -2.63e+06. In the year 1985, what is the difference between the Number of enrolments of both sexes of Gabon and Number of enrolments of both sexes of Korea (Republic)?
Offer a terse response. -4.86e+06. In the year 1985, what is the difference between the Number of enrolments of both sexes in Gabon and Number of enrolments of both sexes in Seychelles?
Your answer should be compact. 1.69e+05. In the year 1985, what is the difference between the Number of enrolments of both sexes of Gabon and Number of enrolments of both sexes of Venezuela?
Make the answer very short. -2.53e+06. In the year 1985, what is the difference between the Number of enrolments of both sexes in Korea (Republic) and Number of enrolments of both sexes in Seychelles?
Make the answer very short. 5.03e+06. In the year 1985, what is the difference between the Number of enrolments of both sexes of Korea (Republic) and Number of enrolments of both sexes of Venezuela?
Provide a succinct answer. 2.33e+06. In the year 1985, what is the difference between the Number of enrolments of both sexes of Seychelles and Number of enrolments of both sexes of Venezuela?
Offer a terse response. -2.70e+06. What is the ratio of the Number of enrolments of both sexes of Gabon in 1979 to that in 1980?
Make the answer very short. 0.95. What is the ratio of the Number of enrolments of both sexes of Seychelles in 1979 to that in 1980?
Keep it short and to the point. 1.04. What is the ratio of the Number of enrolments of both sexes of Venezuela in 1979 to that in 1980?
Your answer should be compact. 0.97. What is the ratio of the Number of enrolments of both sexes in Gabon in 1979 to that in 1981?
Keep it short and to the point. 0.91. What is the ratio of the Number of enrolments of both sexes in Korea (Republic) in 1979 to that in 1981?
Offer a terse response. 0.99. What is the ratio of the Number of enrolments of both sexes in Seychelles in 1979 to that in 1981?
Offer a very short reply. 1.02. What is the ratio of the Number of enrolments of both sexes of Venezuela in 1979 to that in 1981?
Make the answer very short. 0.94. What is the ratio of the Number of enrolments of both sexes of Gabon in 1979 to that in 1982?
Ensure brevity in your answer.  0.88. What is the ratio of the Number of enrolments of both sexes of Korea (Republic) in 1979 to that in 1982?
Your response must be concise. 1. What is the ratio of the Number of enrolments of both sexes in Seychelles in 1979 to that in 1982?
Your answer should be compact. 1.01. What is the ratio of the Number of enrolments of both sexes in Venezuela in 1979 to that in 1982?
Offer a very short reply. 0.92. What is the ratio of the Number of enrolments of both sexes of Gabon in 1979 to that in 1983?
Keep it short and to the point. 0.86. What is the ratio of the Number of enrolments of both sexes of Korea (Republic) in 1979 to that in 1983?
Provide a succinct answer. 1.03. What is the ratio of the Number of enrolments of both sexes in Seychelles in 1979 to that in 1983?
Your response must be concise. 1.02. What is the ratio of the Number of enrolments of both sexes in Venezuela in 1979 to that in 1983?
Your answer should be compact. 0.91. What is the ratio of the Number of enrolments of both sexes in Gabon in 1979 to that in 1984?
Your answer should be compact. 0.82. What is the ratio of the Number of enrolments of both sexes in Korea (Republic) in 1979 to that in 1984?
Your answer should be very brief. 1.07. What is the ratio of the Number of enrolments of both sexes of Seychelles in 1979 to that in 1984?
Provide a succinct answer. 1.04. What is the ratio of the Number of enrolments of both sexes in Venezuela in 1979 to that in 1984?
Offer a terse response. 0.9. What is the ratio of the Number of enrolments of both sexes of Gabon in 1979 to that in 1985?
Your answer should be compact. 0.79. What is the ratio of the Number of enrolments of both sexes in Korea (Republic) in 1979 to that in 1985?
Ensure brevity in your answer.  1.11. What is the ratio of the Number of enrolments of both sexes in Seychelles in 1979 to that in 1985?
Your answer should be compact. 1.03. What is the ratio of the Number of enrolments of both sexes of Venezuela in 1979 to that in 1985?
Give a very brief answer. 0.88. What is the ratio of the Number of enrolments of both sexes of Gabon in 1980 to that in 1981?
Your answer should be compact. 0.96. What is the ratio of the Number of enrolments of both sexes of Seychelles in 1980 to that in 1981?
Offer a terse response. 0.98. What is the ratio of the Number of enrolments of both sexes in Venezuela in 1980 to that in 1981?
Ensure brevity in your answer.  0.97. What is the ratio of the Number of enrolments of both sexes in Gabon in 1980 to that in 1982?
Ensure brevity in your answer.  0.93. What is the ratio of the Number of enrolments of both sexes in Korea (Republic) in 1980 to that in 1982?
Give a very brief answer. 1.01. What is the ratio of the Number of enrolments of both sexes in Seychelles in 1980 to that in 1982?
Your answer should be very brief. 0.97. What is the ratio of the Number of enrolments of both sexes in Venezuela in 1980 to that in 1982?
Ensure brevity in your answer.  0.95. What is the ratio of the Number of enrolments of both sexes of Gabon in 1980 to that in 1983?
Offer a very short reply. 0.9. What is the ratio of the Number of enrolments of both sexes of Korea (Republic) in 1980 to that in 1983?
Ensure brevity in your answer.  1.03. What is the ratio of the Number of enrolments of both sexes in Seychelles in 1980 to that in 1983?
Make the answer very short. 0.98. What is the ratio of the Number of enrolments of both sexes of Venezuela in 1980 to that in 1983?
Keep it short and to the point. 0.94. What is the ratio of the Number of enrolments of both sexes of Gabon in 1980 to that in 1984?
Make the answer very short. 0.86. What is the ratio of the Number of enrolments of both sexes of Korea (Republic) in 1980 to that in 1984?
Provide a succinct answer. 1.07. What is the ratio of the Number of enrolments of both sexes in Venezuela in 1980 to that in 1984?
Provide a short and direct response. 0.93. What is the ratio of the Number of enrolments of both sexes of Gabon in 1980 to that in 1985?
Your response must be concise. 0.83. What is the ratio of the Number of enrolments of both sexes of Korea (Republic) in 1980 to that in 1985?
Make the answer very short. 1.12. What is the ratio of the Number of enrolments of both sexes of Seychelles in 1980 to that in 1985?
Offer a very short reply. 0.99. What is the ratio of the Number of enrolments of both sexes of Venezuela in 1980 to that in 1985?
Offer a very short reply. 0.91. What is the ratio of the Number of enrolments of both sexes of Gabon in 1981 to that in 1982?
Your answer should be very brief. 0.97. What is the ratio of the Number of enrolments of both sexes in Korea (Republic) in 1981 to that in 1982?
Ensure brevity in your answer.  1.01. What is the ratio of the Number of enrolments of both sexes of Venezuela in 1981 to that in 1982?
Offer a terse response. 0.98. What is the ratio of the Number of enrolments of both sexes in Gabon in 1981 to that in 1983?
Give a very brief answer. 0.94. What is the ratio of the Number of enrolments of both sexes in Korea (Republic) in 1981 to that in 1983?
Ensure brevity in your answer.  1.04. What is the ratio of the Number of enrolments of both sexes in Venezuela in 1981 to that in 1983?
Provide a succinct answer. 0.97. What is the ratio of the Number of enrolments of both sexes in Gabon in 1981 to that in 1984?
Keep it short and to the point. 0.9. What is the ratio of the Number of enrolments of both sexes in Korea (Republic) in 1981 to that in 1984?
Keep it short and to the point. 1.08. What is the ratio of the Number of enrolments of both sexes of Venezuela in 1981 to that in 1984?
Give a very brief answer. 0.96. What is the ratio of the Number of enrolments of both sexes in Gabon in 1981 to that in 1985?
Your answer should be compact. 0.87. What is the ratio of the Number of enrolments of both sexes in Korea (Republic) in 1981 to that in 1985?
Provide a short and direct response. 1.12. What is the ratio of the Number of enrolments of both sexes in Seychelles in 1981 to that in 1985?
Give a very brief answer. 1.01. What is the ratio of the Number of enrolments of both sexes in Venezuela in 1981 to that in 1985?
Make the answer very short. 0.93. What is the ratio of the Number of enrolments of both sexes of Gabon in 1982 to that in 1983?
Your response must be concise. 0.97. What is the ratio of the Number of enrolments of both sexes in Korea (Republic) in 1982 to that in 1983?
Make the answer very short. 1.02. What is the ratio of the Number of enrolments of both sexes in Seychelles in 1982 to that in 1983?
Make the answer very short. 1.01. What is the ratio of the Number of enrolments of both sexes in Gabon in 1982 to that in 1984?
Your answer should be very brief. 0.93. What is the ratio of the Number of enrolments of both sexes in Korea (Republic) in 1982 to that in 1984?
Offer a very short reply. 1.06. What is the ratio of the Number of enrolments of both sexes in Seychelles in 1982 to that in 1984?
Offer a very short reply. 1.03. What is the ratio of the Number of enrolments of both sexes of Venezuela in 1982 to that in 1984?
Ensure brevity in your answer.  0.98. What is the ratio of the Number of enrolments of both sexes in Gabon in 1982 to that in 1985?
Keep it short and to the point. 0.9. What is the ratio of the Number of enrolments of both sexes of Korea (Republic) in 1982 to that in 1985?
Give a very brief answer. 1.11. What is the ratio of the Number of enrolments of both sexes of Seychelles in 1982 to that in 1985?
Provide a short and direct response. 1.02. What is the ratio of the Number of enrolments of both sexes of Venezuela in 1982 to that in 1985?
Give a very brief answer. 0.96. What is the ratio of the Number of enrolments of both sexes in Gabon in 1983 to that in 1984?
Your answer should be compact. 0.96. What is the ratio of the Number of enrolments of both sexes of Korea (Republic) in 1983 to that in 1984?
Ensure brevity in your answer.  1.04. What is the ratio of the Number of enrolments of both sexes in Seychelles in 1983 to that in 1984?
Ensure brevity in your answer.  1.02. What is the ratio of the Number of enrolments of both sexes in Venezuela in 1983 to that in 1984?
Provide a short and direct response. 0.99. What is the ratio of the Number of enrolments of both sexes of Gabon in 1983 to that in 1985?
Provide a succinct answer. 0.93. What is the ratio of the Number of enrolments of both sexes in Korea (Republic) in 1983 to that in 1985?
Offer a terse response. 1.08. What is the ratio of the Number of enrolments of both sexes of Seychelles in 1983 to that in 1985?
Your response must be concise. 1.01. What is the ratio of the Number of enrolments of both sexes in Venezuela in 1983 to that in 1985?
Provide a succinct answer. 0.97. What is the ratio of the Number of enrolments of both sexes in Gabon in 1984 to that in 1985?
Provide a short and direct response. 0.96. What is the ratio of the Number of enrolments of both sexes in Korea (Republic) in 1984 to that in 1985?
Make the answer very short. 1.04. What is the ratio of the Number of enrolments of both sexes in Seychelles in 1984 to that in 1985?
Provide a succinct answer. 0.99. What is the ratio of the Number of enrolments of both sexes of Venezuela in 1984 to that in 1985?
Make the answer very short. 0.97. What is the difference between the highest and the second highest Number of enrolments of both sexes in Gabon?
Ensure brevity in your answer.  6612. What is the difference between the highest and the second highest Number of enrolments of both sexes in Korea (Republic)?
Offer a very short reply. 1.73e+04. What is the difference between the highest and the second highest Number of enrolments of both sexes in Seychelles?
Provide a succinct answer. 81. What is the difference between the highest and the second highest Number of enrolments of both sexes in Venezuela?
Ensure brevity in your answer.  6.90e+04. What is the difference between the highest and the lowest Number of enrolments of both sexes of Gabon?
Give a very brief answer. 3.72e+04. What is the difference between the highest and the lowest Number of enrolments of both sexes of Korea (Republic)?
Keep it short and to the point. 6.17e+05. What is the difference between the highest and the lowest Number of enrolments of both sexes of Seychelles?
Offer a very short reply. 371. What is the difference between the highest and the lowest Number of enrolments of both sexes of Venezuela?
Make the answer very short. 3.32e+05. 